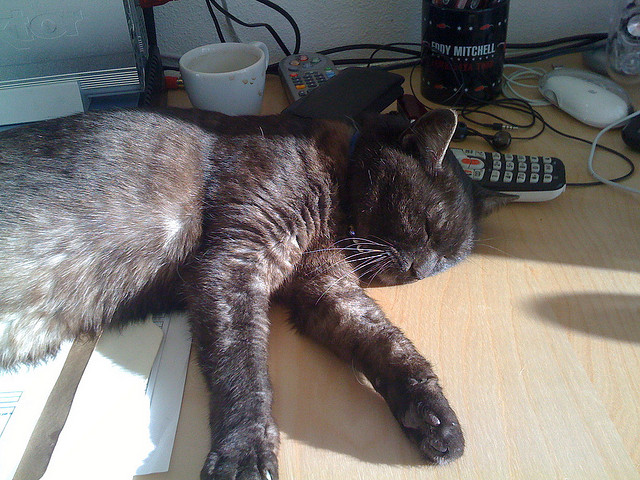Please transcribe the text information in this image. MITCHELL 